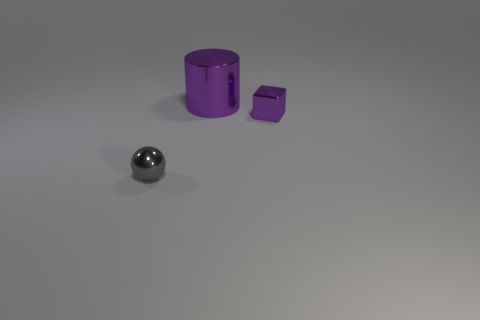Is the number of small purple shiny things to the left of the gray object greater than the number of cubes on the right side of the small purple block?
Provide a succinct answer. No. What number of tiny balls are the same material as the small purple object?
Keep it short and to the point. 1. There is a purple metal object to the right of the large cylinder; is it the same shape as the small thing that is on the left side of the big metallic cylinder?
Give a very brief answer. No. There is a thing left of the large purple cylinder; what color is it?
Your answer should be very brief. Gray. Is there a small purple metal object that has the same shape as the gray metal object?
Offer a very short reply. No. What is the material of the large purple cylinder?
Your answer should be very brief. Metal. What size is the object that is both behind the metal sphere and in front of the purple shiny cylinder?
Give a very brief answer. Small. There is a large thing that is the same color as the cube; what material is it?
Your response must be concise. Metal. How many brown rubber spheres are there?
Your answer should be compact. 0. Is the number of objects less than the number of brown shiny objects?
Keep it short and to the point. No. 